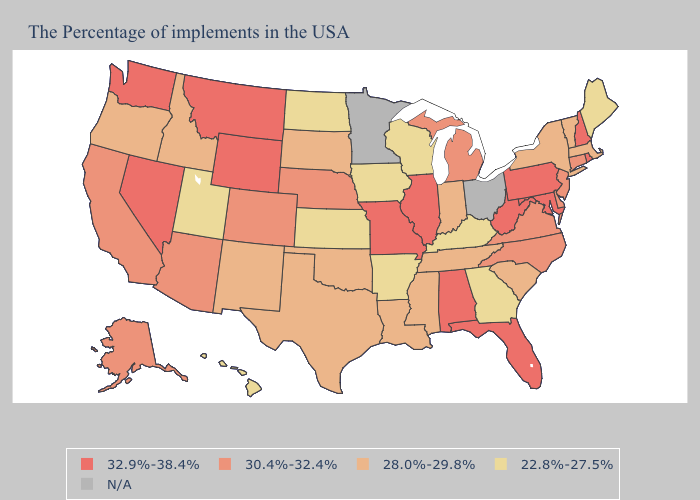Does New Jersey have the highest value in the Northeast?
Be succinct. No. What is the lowest value in the MidWest?
Keep it brief. 22.8%-27.5%. Among the states that border Oregon , does Idaho have the lowest value?
Answer briefly. Yes. Name the states that have a value in the range 22.8%-27.5%?
Keep it brief. Maine, Georgia, Kentucky, Wisconsin, Arkansas, Iowa, Kansas, North Dakota, Utah, Hawaii. Among the states that border Oregon , does Washington have the highest value?
Be succinct. Yes. Name the states that have a value in the range 30.4%-32.4%?
Write a very short answer. Connecticut, New Jersey, Delaware, Virginia, North Carolina, Michigan, Nebraska, Colorado, Arizona, California, Alaska. Name the states that have a value in the range 28.0%-29.8%?
Quick response, please. Massachusetts, Vermont, New York, South Carolina, Indiana, Tennessee, Mississippi, Louisiana, Oklahoma, Texas, South Dakota, New Mexico, Idaho, Oregon. What is the value of Nevada?
Quick response, please. 32.9%-38.4%. What is the highest value in the South ?
Short answer required. 32.9%-38.4%. What is the highest value in the USA?
Keep it brief. 32.9%-38.4%. What is the value of Minnesota?
Give a very brief answer. N/A. Name the states that have a value in the range 22.8%-27.5%?
Write a very short answer. Maine, Georgia, Kentucky, Wisconsin, Arkansas, Iowa, Kansas, North Dakota, Utah, Hawaii. Name the states that have a value in the range N/A?
Be succinct. Ohio, Minnesota. What is the value of Oklahoma?
Be succinct. 28.0%-29.8%. 